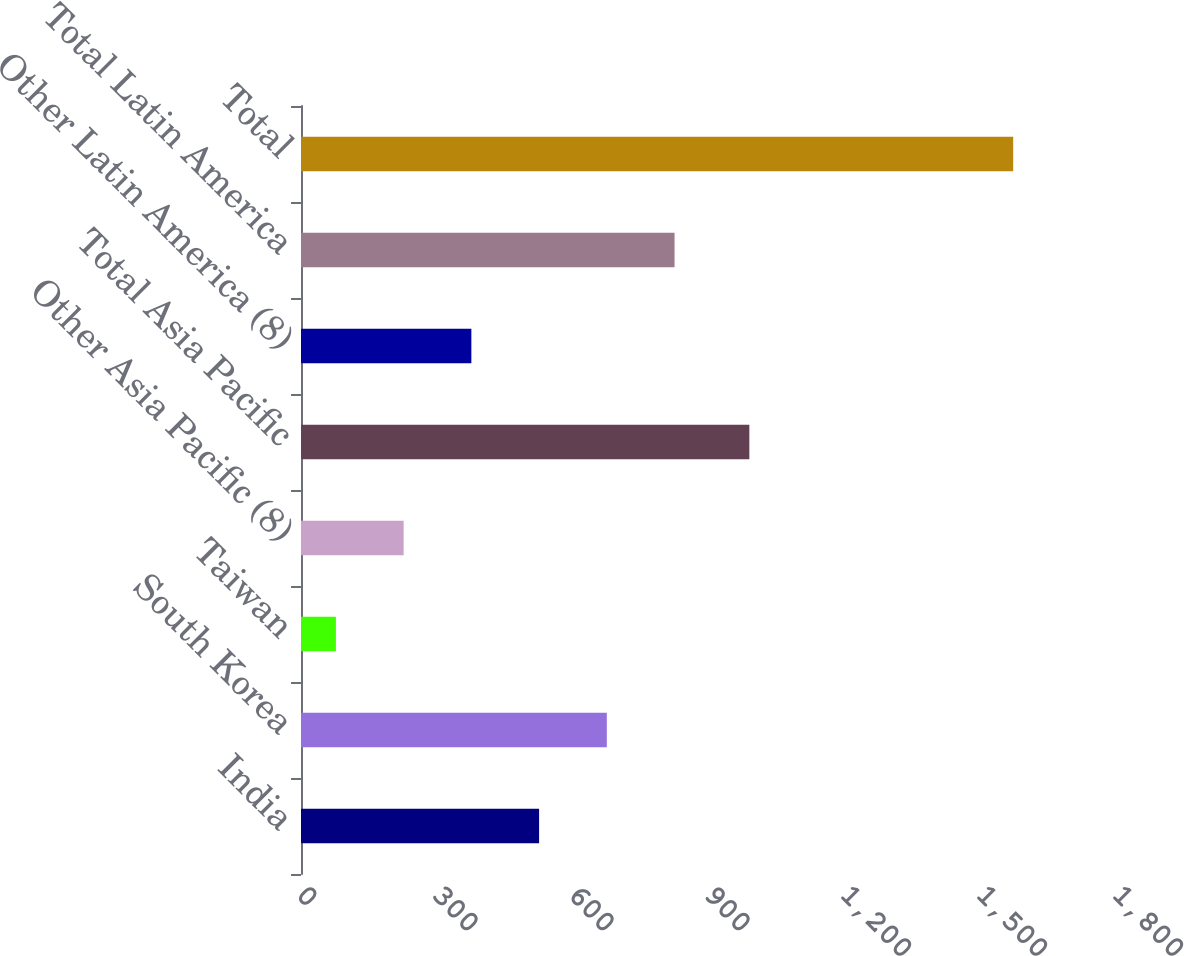Convert chart to OTSL. <chart><loc_0><loc_0><loc_500><loc_500><bar_chart><fcel>India<fcel>South Korea<fcel>Taiwan<fcel>Other Asia Pacific (8)<fcel>Total Asia Pacific<fcel>Other Latin America (8)<fcel>Total Latin America<fcel>Total<nl><fcel>525.2<fcel>674.6<fcel>77<fcel>226.4<fcel>989<fcel>375.8<fcel>824<fcel>1571<nl></chart> 